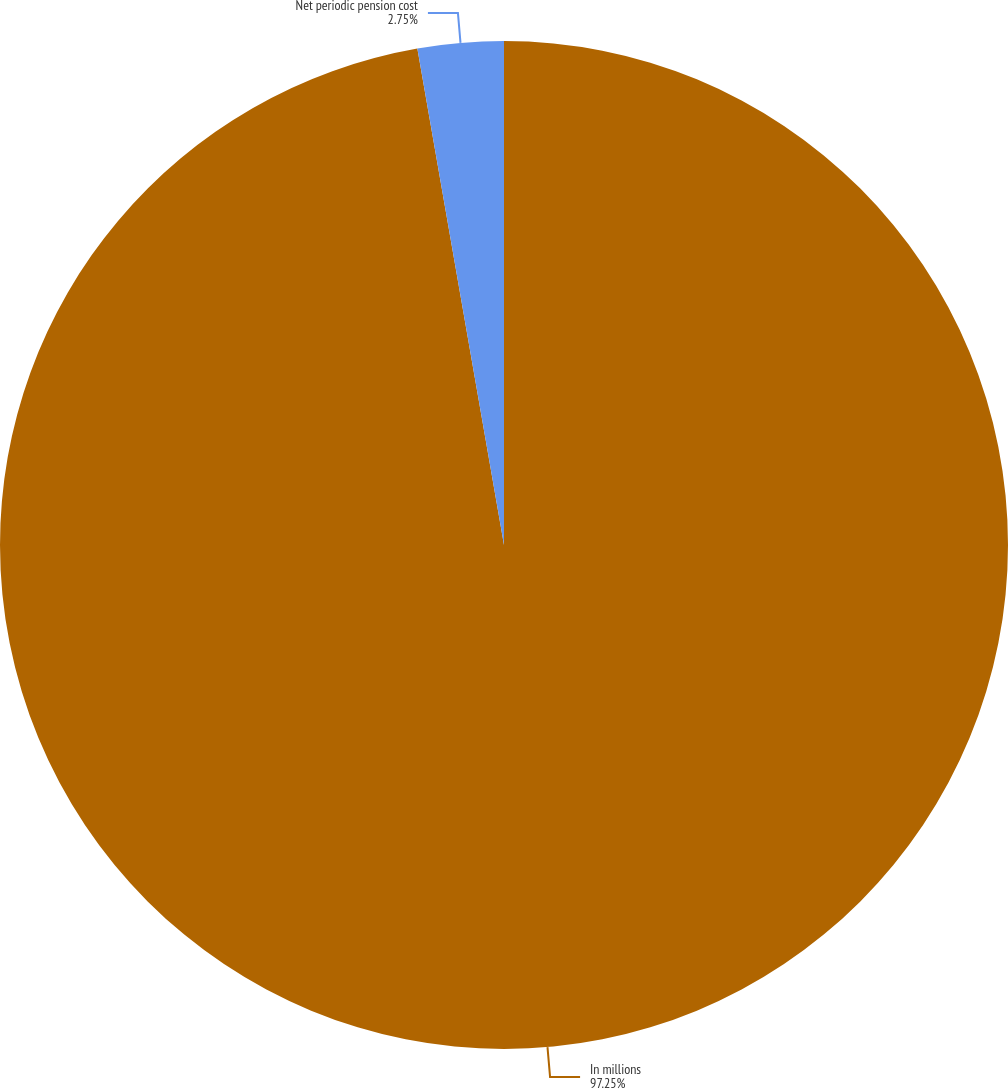Convert chart to OTSL. <chart><loc_0><loc_0><loc_500><loc_500><pie_chart><fcel>In millions<fcel>Net periodic pension cost<nl><fcel>97.25%<fcel>2.75%<nl></chart> 